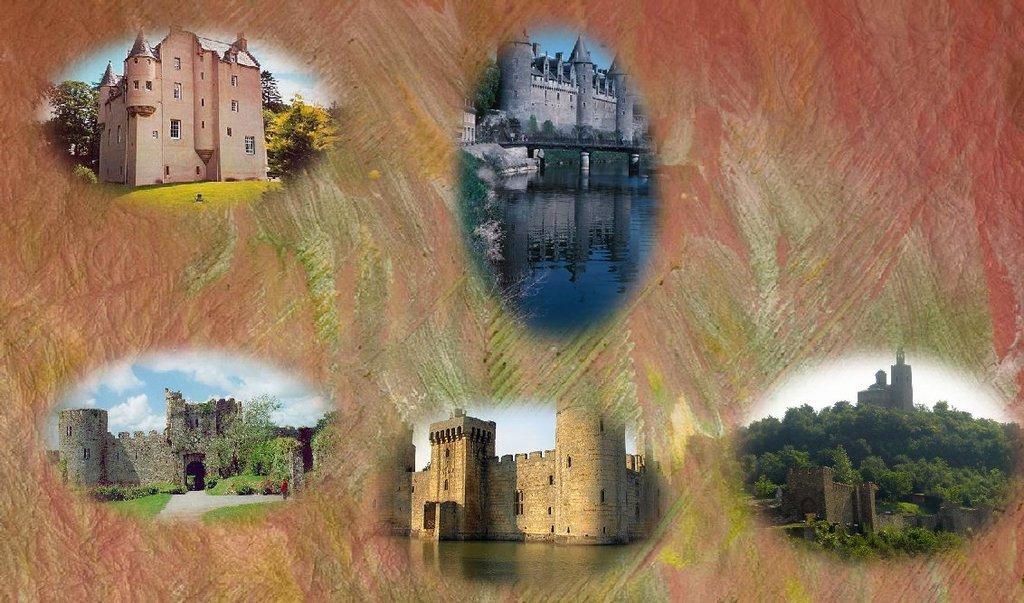How would you summarize this image in a sentence or two? In this picture we can see a few buildings, trees, forests and water. 